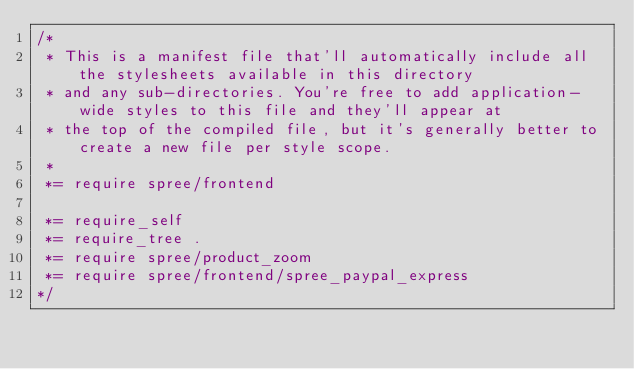<code> <loc_0><loc_0><loc_500><loc_500><_CSS_>/*
 * This is a manifest file that'll automatically include all the stylesheets available in this directory
 * and any sub-directories. You're free to add application-wide styles to this file and they'll appear at
 * the top of the compiled file, but it's generally better to create a new file per style scope.
 *
 *= require spree/frontend

 *= require_self
 *= require_tree .
 *= require spree/product_zoom
 *= require spree/frontend/spree_paypal_express
*/
</code> 